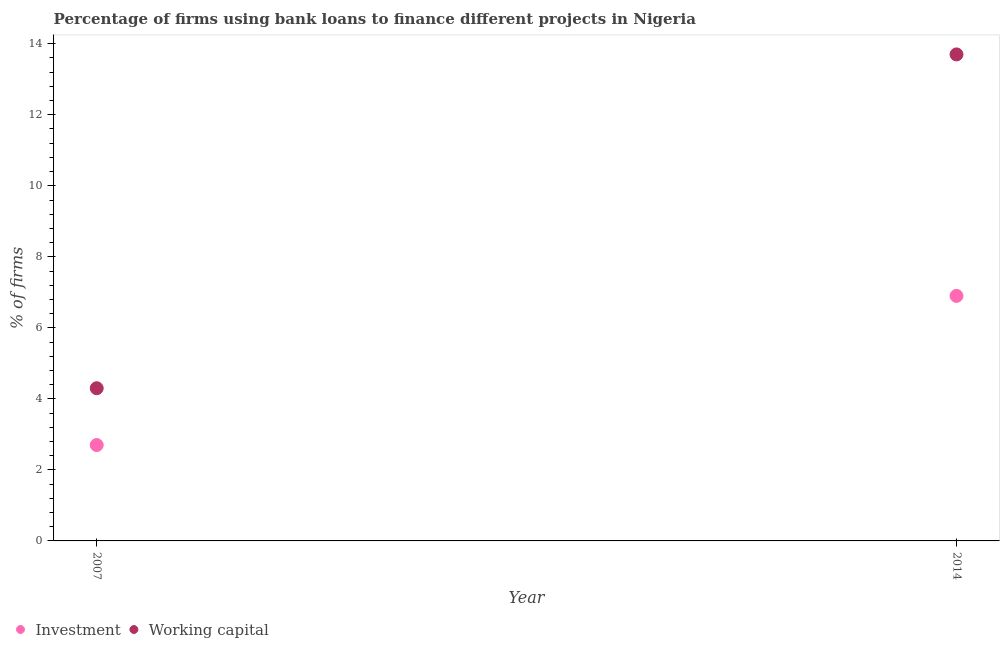Is the number of dotlines equal to the number of legend labels?
Offer a very short reply. Yes. What is the percentage of firms using banks to finance working capital in 2007?
Your answer should be very brief. 4.3. Across all years, what is the minimum percentage of firms using banks to finance working capital?
Offer a terse response. 4.3. In which year was the percentage of firms using banks to finance investment minimum?
Your answer should be compact. 2007. What is the total percentage of firms using banks to finance working capital in the graph?
Give a very brief answer. 18. What is the difference between the percentage of firms using banks to finance working capital in 2007 and that in 2014?
Your answer should be compact. -9.4. What is the difference between the percentage of firms using banks to finance working capital in 2007 and the percentage of firms using banks to finance investment in 2014?
Give a very brief answer. -2.6. What is the average percentage of firms using banks to finance investment per year?
Give a very brief answer. 4.8. In the year 2014, what is the difference between the percentage of firms using banks to finance investment and percentage of firms using banks to finance working capital?
Your response must be concise. -6.8. In how many years, is the percentage of firms using banks to finance investment greater than 7.6 %?
Ensure brevity in your answer.  0. What is the ratio of the percentage of firms using banks to finance investment in 2007 to that in 2014?
Give a very brief answer. 0.39. Does the percentage of firms using banks to finance working capital monotonically increase over the years?
Make the answer very short. Yes. Is the percentage of firms using banks to finance working capital strictly greater than the percentage of firms using banks to finance investment over the years?
Give a very brief answer. Yes. Is the percentage of firms using banks to finance investment strictly less than the percentage of firms using banks to finance working capital over the years?
Your response must be concise. Yes. How many years are there in the graph?
Offer a terse response. 2. What is the difference between two consecutive major ticks on the Y-axis?
Your response must be concise. 2. Does the graph contain any zero values?
Your answer should be very brief. No. Does the graph contain grids?
Provide a succinct answer. No. How many legend labels are there?
Ensure brevity in your answer.  2. How are the legend labels stacked?
Ensure brevity in your answer.  Horizontal. What is the title of the graph?
Provide a succinct answer. Percentage of firms using bank loans to finance different projects in Nigeria. Does "Public funds" appear as one of the legend labels in the graph?
Your response must be concise. No. What is the label or title of the X-axis?
Ensure brevity in your answer.  Year. What is the label or title of the Y-axis?
Your answer should be very brief. % of firms. What is the % of firms in Investment in 2007?
Offer a very short reply. 2.7. What is the % of firms in Investment in 2014?
Your answer should be compact. 6.9. What is the % of firms in Working capital in 2014?
Offer a very short reply. 13.7. Across all years, what is the maximum % of firms in Investment?
Make the answer very short. 6.9. Across all years, what is the maximum % of firms in Working capital?
Your answer should be compact. 13.7. What is the difference between the % of firms of Working capital in 2007 and that in 2014?
Provide a succinct answer. -9.4. What is the difference between the % of firms of Investment in 2007 and the % of firms of Working capital in 2014?
Your answer should be very brief. -11. What is the ratio of the % of firms in Investment in 2007 to that in 2014?
Give a very brief answer. 0.39. What is the ratio of the % of firms in Working capital in 2007 to that in 2014?
Give a very brief answer. 0.31. What is the difference between the highest and the second highest % of firms in Working capital?
Keep it short and to the point. 9.4. What is the difference between the highest and the lowest % of firms of Investment?
Offer a very short reply. 4.2. 